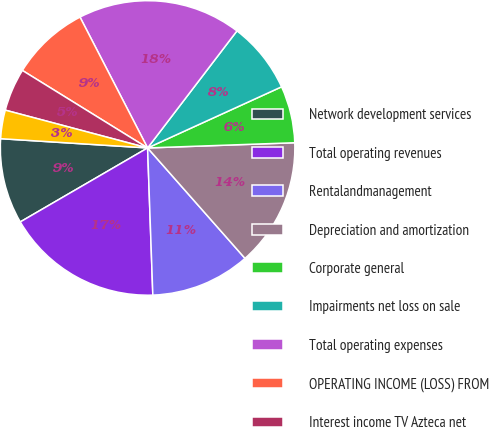Convert chart. <chart><loc_0><loc_0><loc_500><loc_500><pie_chart><fcel>Network development services<fcel>Total operating revenues<fcel>Rentalandmanagement<fcel>Depreciation and amortization<fcel>Corporate general<fcel>Impairments net loss on sale<fcel>Total operating expenses<fcel>OPERATING INCOME (LOSS) FROM<fcel>Interest income TV Azteca net<fcel>Interest income<nl><fcel>9.38%<fcel>17.19%<fcel>10.94%<fcel>14.06%<fcel>6.25%<fcel>7.81%<fcel>17.97%<fcel>8.59%<fcel>4.69%<fcel>3.13%<nl></chart> 